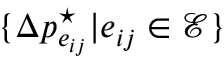Convert formula to latex. <formula><loc_0><loc_0><loc_500><loc_500>\{ \Delta p _ { e _ { i j } } ^ { ^ { * } } | e _ { i j } \in \mathcal { E } \}</formula> 